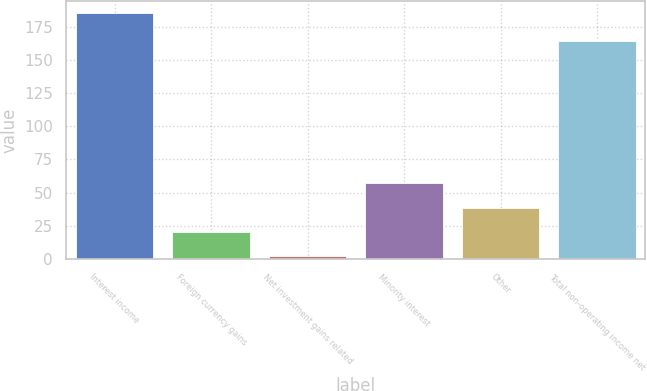Convert chart to OTSL. <chart><loc_0><loc_0><loc_500><loc_500><bar_chart><fcel>Interest income<fcel>Foreign currency gains<fcel>Net investment gains related<fcel>Minority interest<fcel>Other<fcel>Total non-operating income net<nl><fcel>185<fcel>20.3<fcel>2<fcel>56.9<fcel>38.6<fcel>164<nl></chart> 